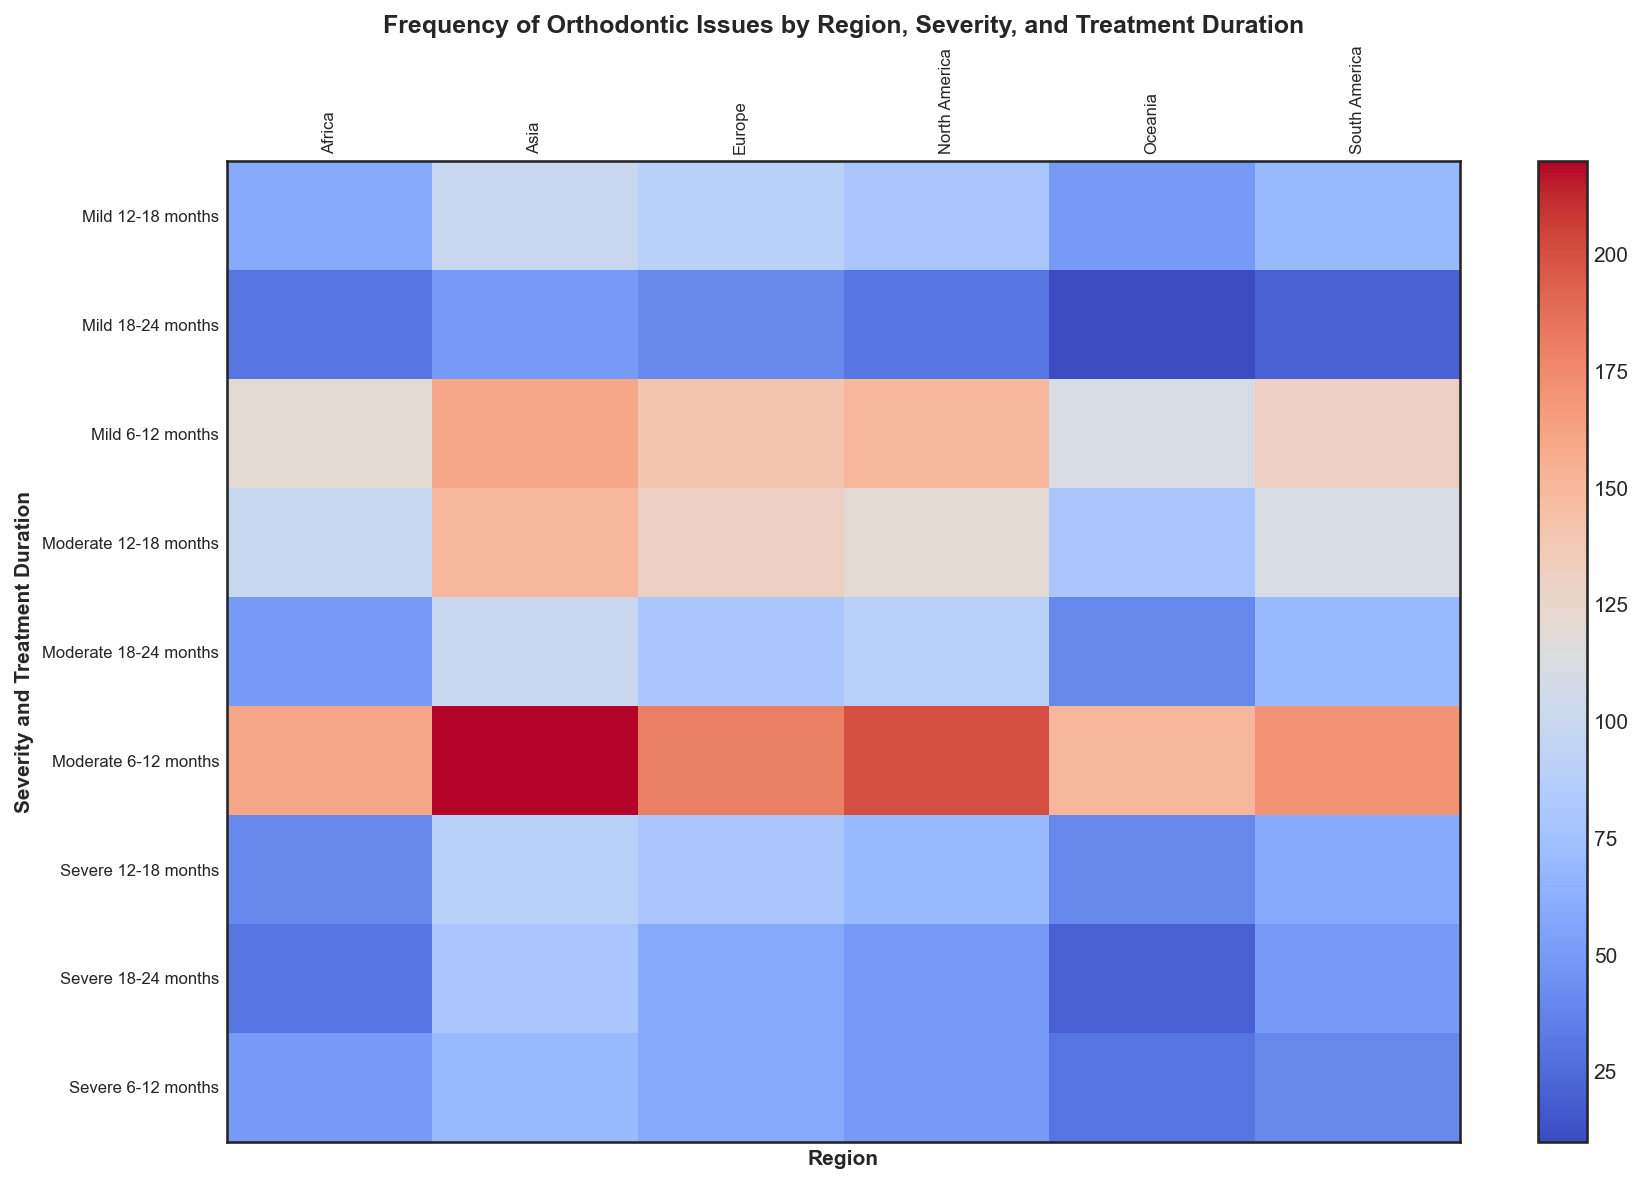Which region has the highest frequency of severe orthodontic issues within 6-12 months of treatment? To find the answer, locate the severe category for 6-12 months treatment duration in each region's column and compare the values. North America: 50, Europe: 60, Asia: 70, South America: 40, Africa: 50, Oceania: 30. Asia has the highest frequency (70).
Answer: Asia Which treatment duration in Europe exhibits the highest frequency for moderate severity? Look for the moderate severity row in Europe's column and compare the values across treatment durations. 6-12 months: 180, 12-18 months: 130, 18-24 months: 80. The highest value is 180 in the 6-12 months duration.
Answer: 6-12 months How does the frequency of mild issues in North America for 12-18 months compare to South America for the same duration? Locate the frequency values for mild issues within 12-18 months in both North America and South America. North America: 80, South America: 70. North America's frequency is higher by 10.
Answer: Higher by 10 What's the combined frequency of mild issues in Asia across all treatment durations? Sum the frequencies of mild issues in Asia across all durations. 6-12 months: 160, 12-18 months: 100, 18-24 months: 50. Thus, the sum is 160 + 100 + 50 = 310.
Answer: 310 Compare the frequencies of severe issues in 18-24 months duration between Asia and Africa, and state which has a higher frequency. Check the severe issues for 18-24 months in Asia and Africa. Asia: 80, Africa: 30. Asia has a higher frequency by 50.
Answer: Asia Which region shows the most frequent orthodontic issues in any severity and duration category, and what is the value? Review the heatmap to identify the highest single value across all regions, severities, and treatment durations. The highest value is 220 for moderate issues in Asia for 6-12 months duration.
Answer: Asia with 220 How do the frequencies compare between moderate issues in Oceania for 6-12 months and severe issues in Africa for 12-18 months? Locate the values for moderate issues in Oceania for 6-12 months and severe issues in Africa for 12-18 months. Oceania: 150, Africa: 40. Moderate issues in Oceania have a higher frequency by 110.
Answer: Higher by 110 What's the difference in frequency of severe issues in 6-12 months duration between Europe and North America? Compare the frequency values of severe issues in 6-12 months duration between Europe and North America. Europe: 60, North America: 50. The difference is 60 - 50 = 10.
Answer: 10 Is the average frequency of moderate issues in North America across all treatment durations higher than 100? Find the frequencies for moderate issues in North America across all durations and calculate the average. Values: 6-12 months: 200, 12-18 months: 120, 18-24 months: 90, sum: 200 + 120 + 90 = 410, average: 410 / 3 ≈ 136.67, which is higher than 100.
Answer: Yes, 136.67 